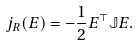Convert formula to latex. <formula><loc_0><loc_0><loc_500><loc_500>j _ { R } ( E ) = - \frac { 1 } { 2 } E ^ { \top } \mathbb { J } E .</formula> 